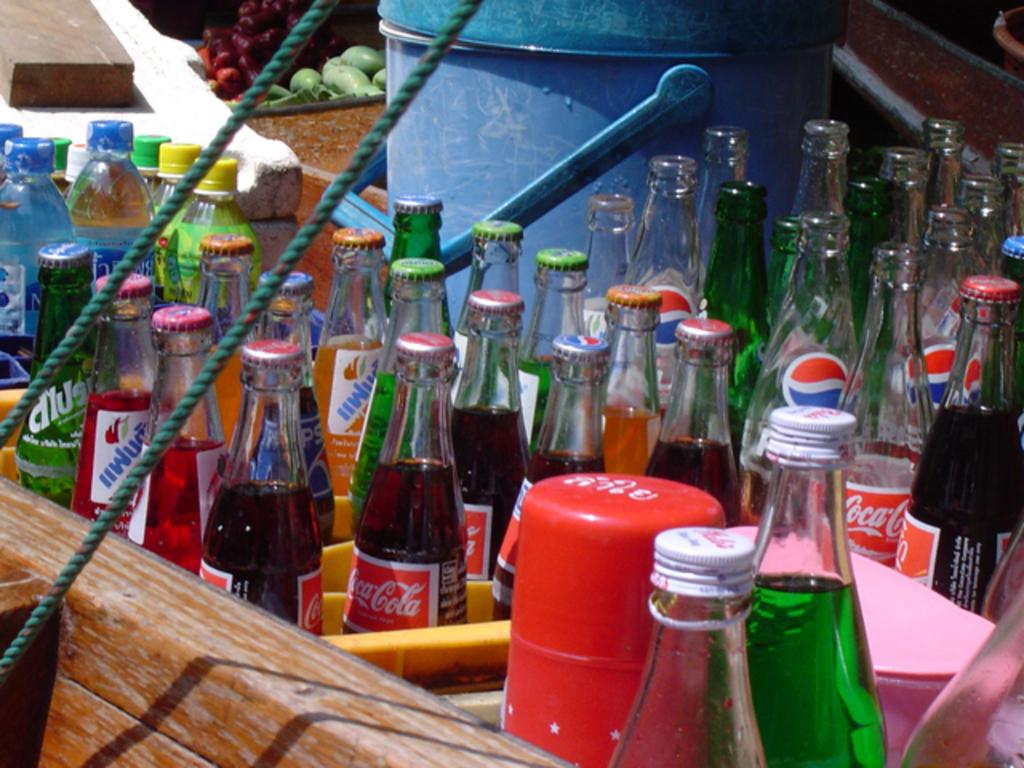<image>
Write a terse but informative summary of the picture. Multiple bottles of soda including pepsi and coke that are open and closed. 